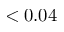Convert formula to latex. <formula><loc_0><loc_0><loc_500><loc_500>< 0 . 0 4</formula> 